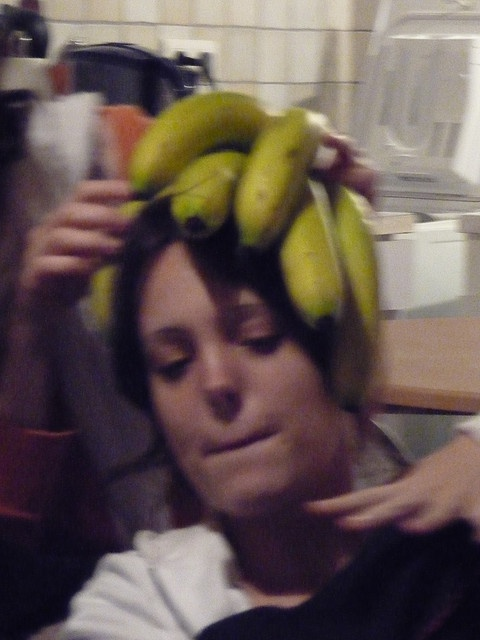Describe the objects in this image and their specific colors. I can see people in tan, black, brown, gray, and maroon tones, people in tan, black, gray, maroon, and brown tones, banana in tan, olive, and black tones, banana in tan, black, and olive tones, and banana in tan, olive, and black tones in this image. 